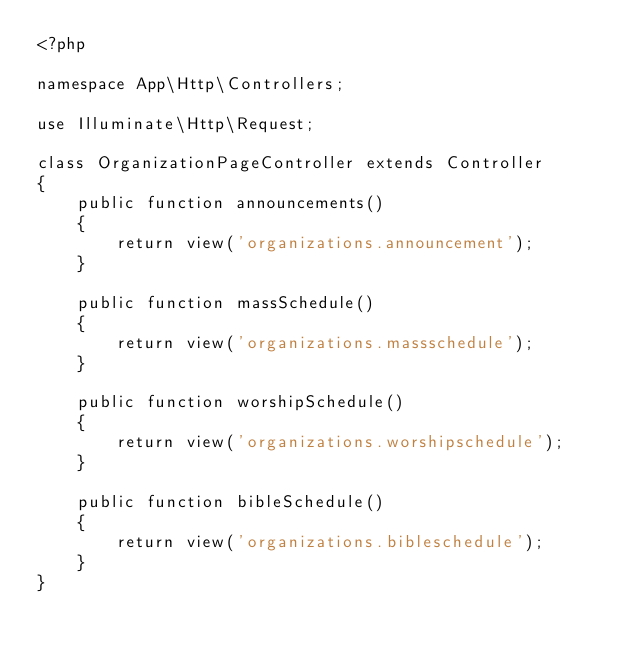<code> <loc_0><loc_0><loc_500><loc_500><_PHP_><?php

namespace App\Http\Controllers;

use Illuminate\Http\Request;

class OrganizationPageController extends Controller
{
    public function announcements()
    {
        return view('organizations.announcement');
    }

    public function massSchedule()
    {
        return view('organizations.massschedule');
    }

    public function worshipSchedule()
    {
        return view('organizations.worshipschedule');
    }

    public function bibleSchedule()
    {
        return view('organizations.bibleschedule');
    }
}
</code> 